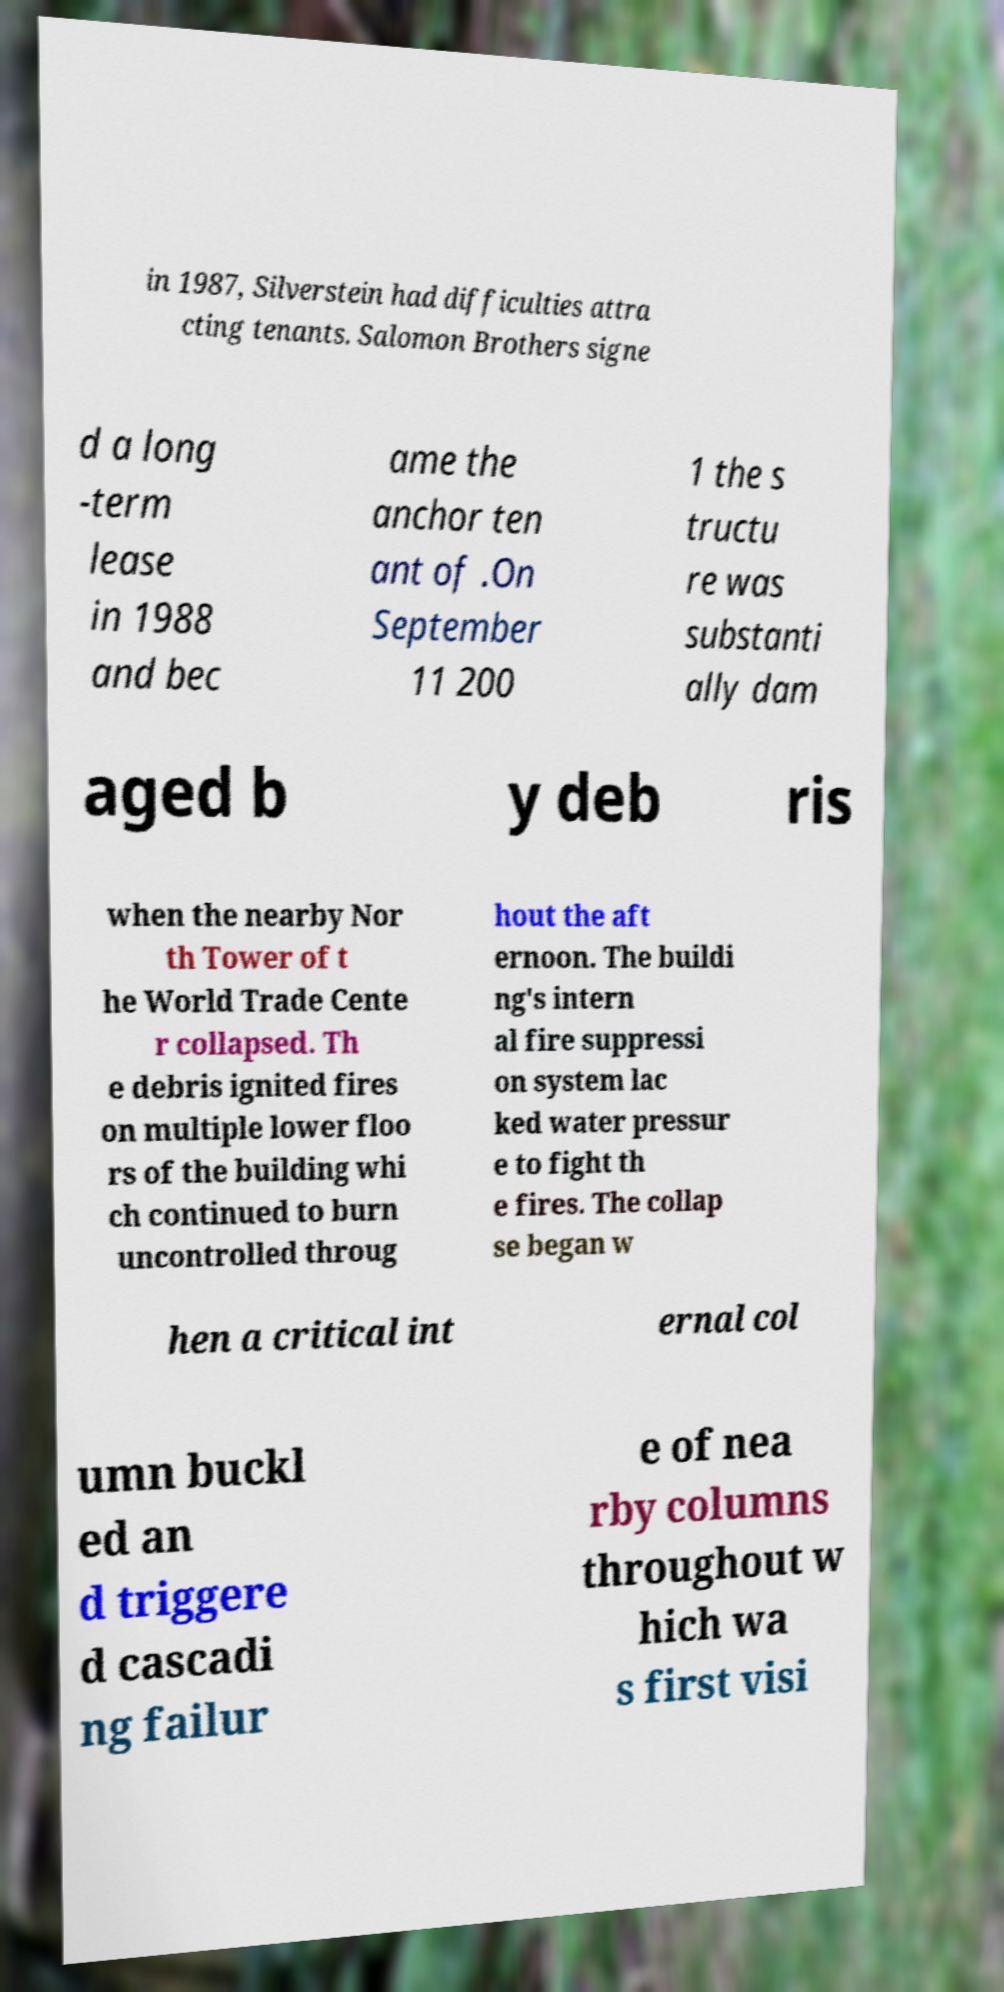I need the written content from this picture converted into text. Can you do that? in 1987, Silverstein had difficulties attra cting tenants. Salomon Brothers signe d a long -term lease in 1988 and bec ame the anchor ten ant of .On September 11 200 1 the s tructu re was substanti ally dam aged b y deb ris when the nearby Nor th Tower of t he World Trade Cente r collapsed. Th e debris ignited fires on multiple lower floo rs of the building whi ch continued to burn uncontrolled throug hout the aft ernoon. The buildi ng's intern al fire suppressi on system lac ked water pressur e to fight th e fires. The collap se began w hen a critical int ernal col umn buckl ed an d triggere d cascadi ng failur e of nea rby columns throughout w hich wa s first visi 